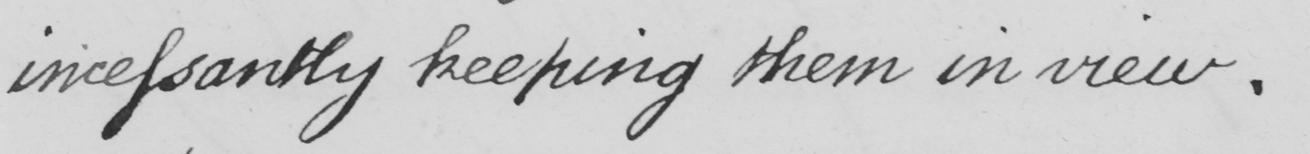Can you read and transcribe this handwriting? incessantly keeping them in view . 